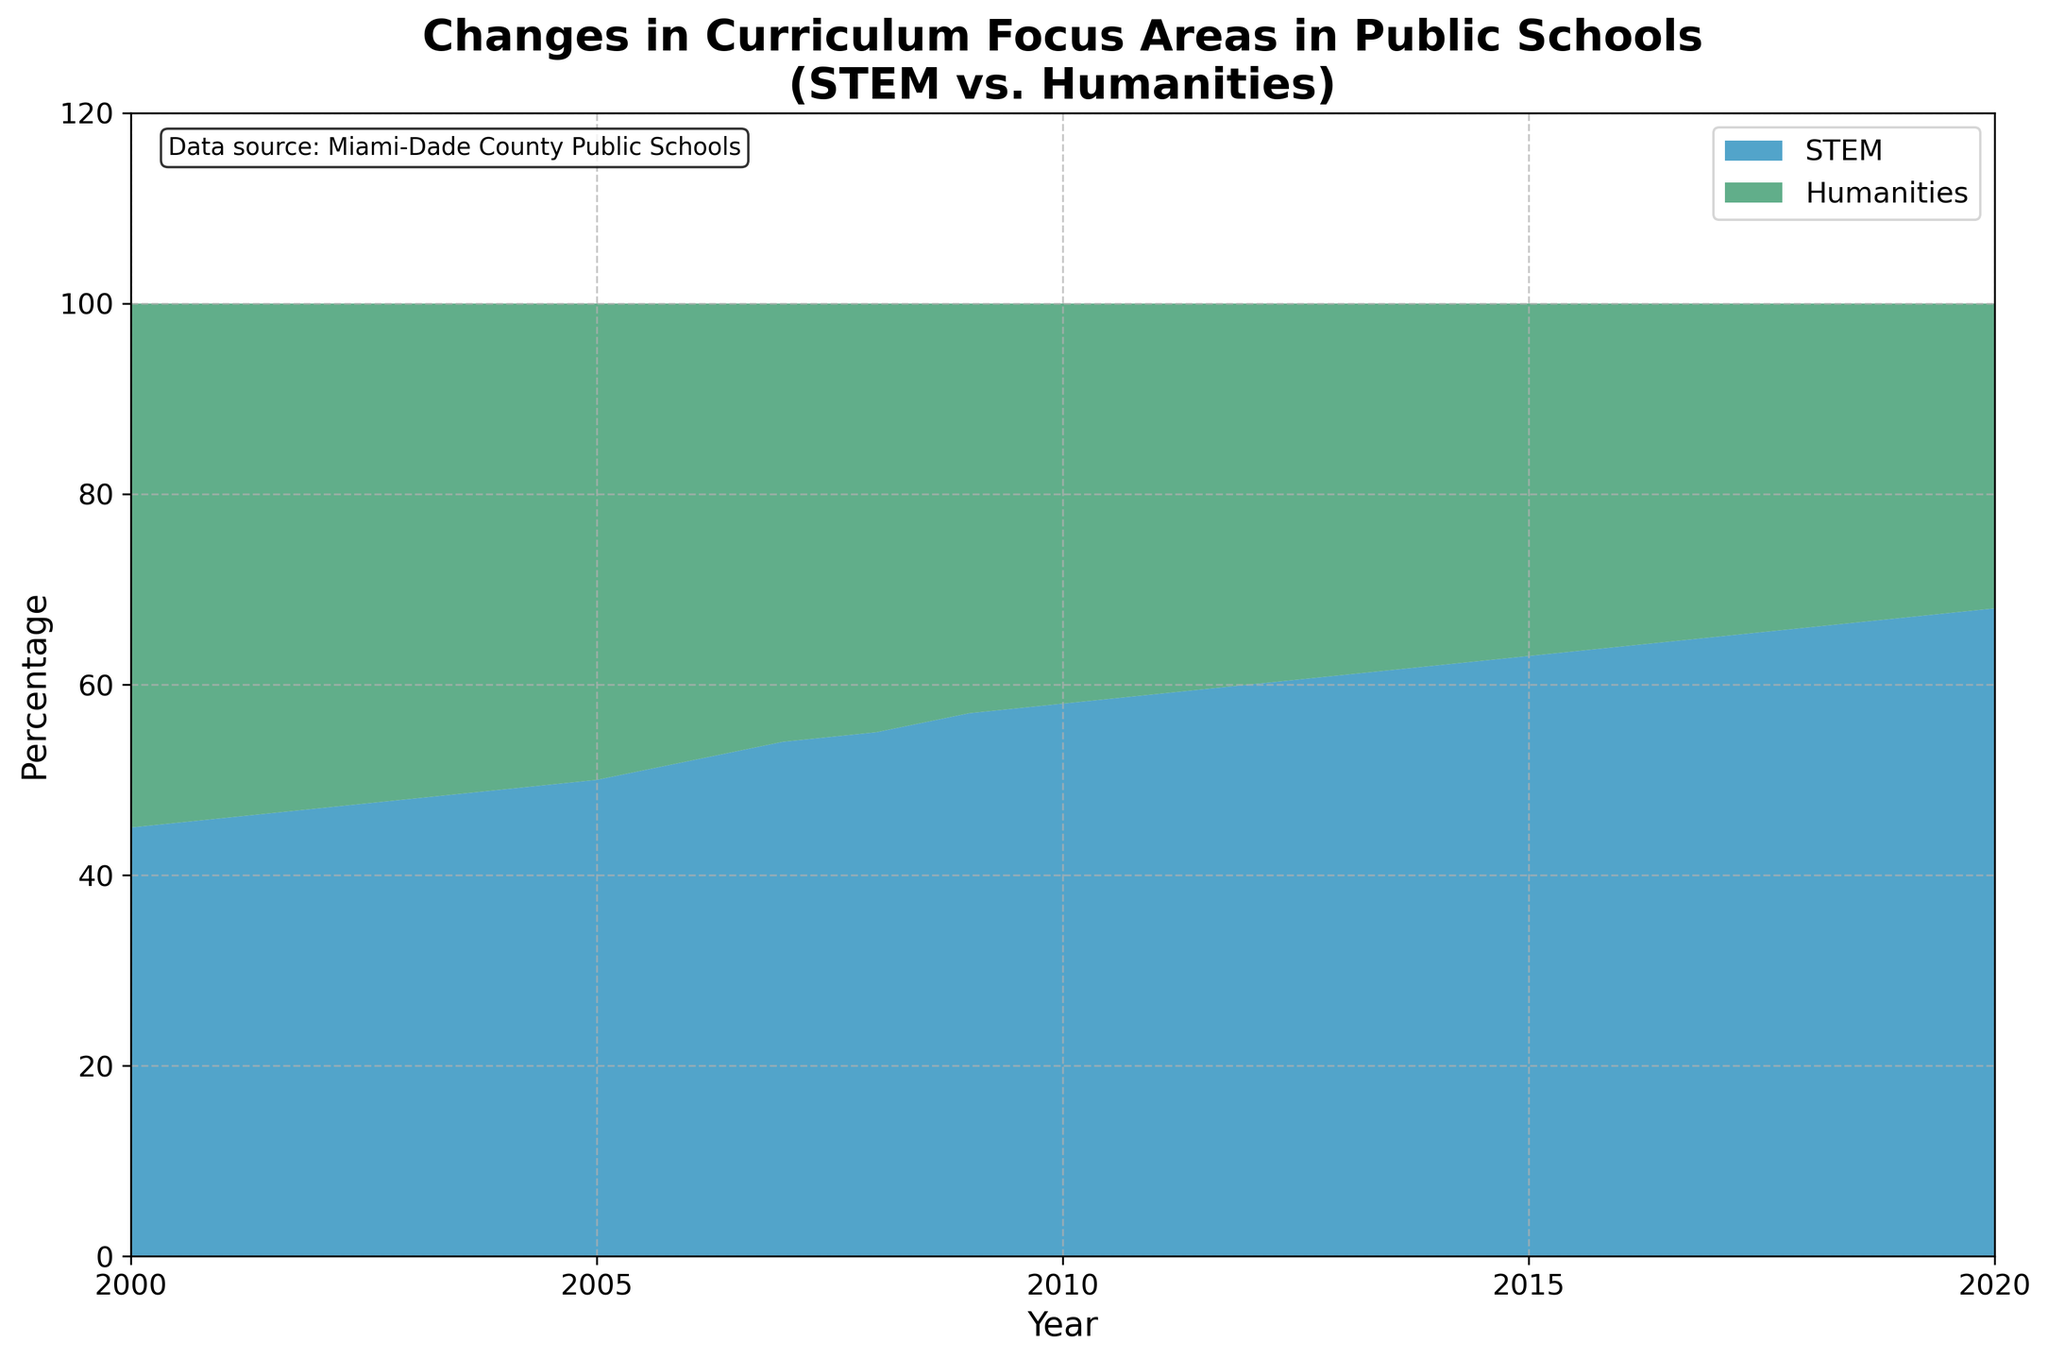what is the title of the figure? The title of the figure is displayed at the top and reads: "Changes in Curriculum Focus Areas in Public Schools\n(STEM vs. Humanities)"
Answer: Changes in Curriculum Focus Areas in Public Schools\n(STEM vs. Humanities) Which axis represents the year? The x-axis at the bottom of the figure represents the year.
Answer: x-axis Which curriculum focus area saw a higher percentage in 2000? In 2000, the STEM area's percentage is shown to be 45%, while the Humanities area's is 55%.
Answer: Humanities In what year did the percentage of STEM equal the percentage of Humanities? Find the point where the two shaded areas meet; it's around the year 2005.
Answer: 2005 What colors represent the STEM and Humanities areas? The STEM area is represented by a shade of blue, and the Humanities area by a shade of green.
Answer: Blue for STEM, Green for Humanities By how much did the STEM percentage increase from 2000 to 2020? The STEM percentage in 2000 was 45%, and in 2020 it was 68%. Thus, the increase is 68% - 45%.
Answer: 23% What is the combined total percentage of STEM and Humanities for each year? The combined percentage of STEM and Humanities always adds up to 100% each year.
Answer: 100% Compare the trend of STEM and Humanities focus areas from 2000 to 2020. Which area consistently increased? Observing the trends, the STEM focus area consistently increased over time, while the Humanities focus area consistently decreased.
Answer: STEM What percentage did the Humanities area drop to in 2008? In 2008, the Humanities area's percentage dropped to 45%.
Answer: 45% What is the overall rate of growth for STEM from 2000 to 2020? Calculate the percentage increase over the years. The STEM percentage increased from 45% in 2000 to 68% in 2020. The overall growth rate can be calculated as ((68 - 45) / 45) * 100%.
Answer: 51.11% 